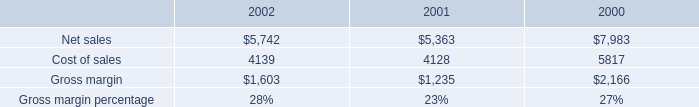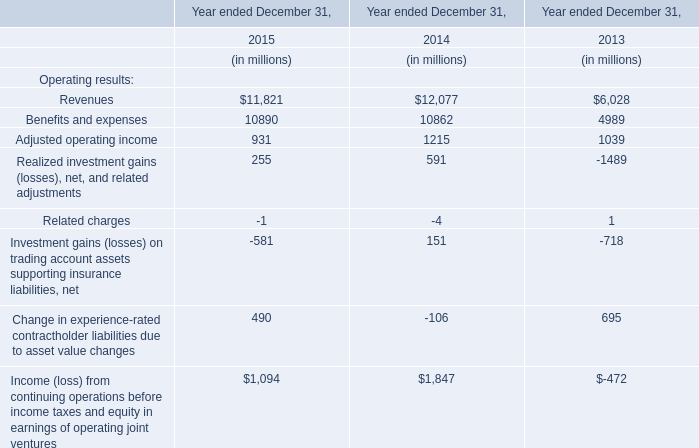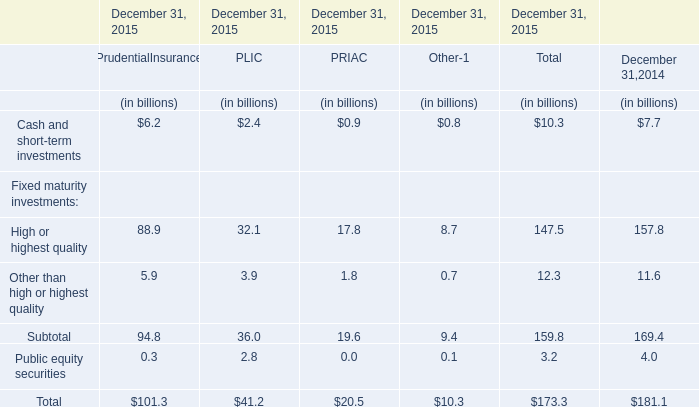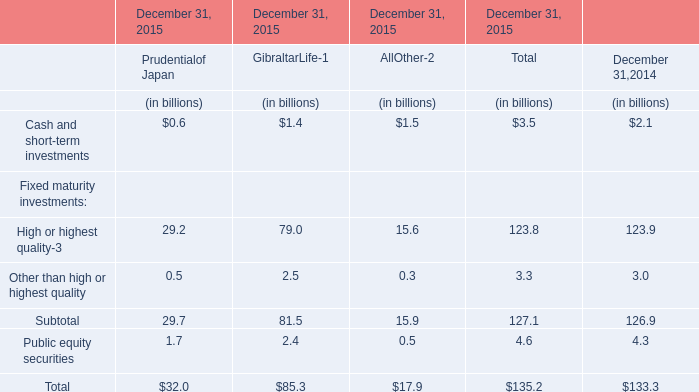What's the total value of all elements for Total that are smaller than 120 in 2015? (in billion) 
Computations: ((3.5 + 3.3) + 4.6)
Answer: 11.4. 